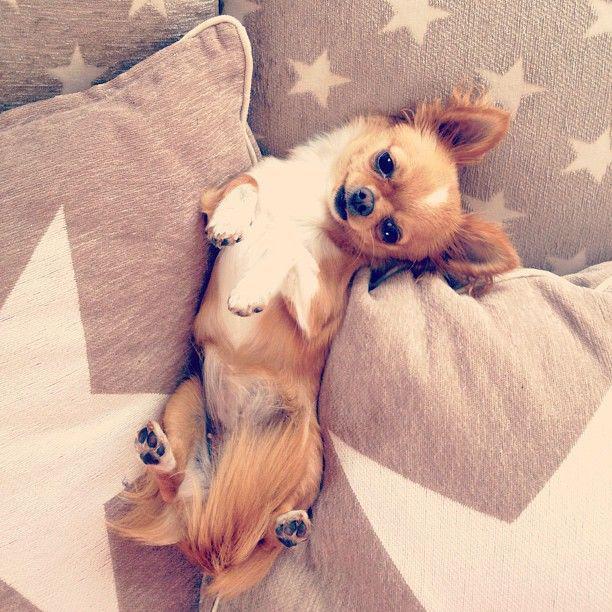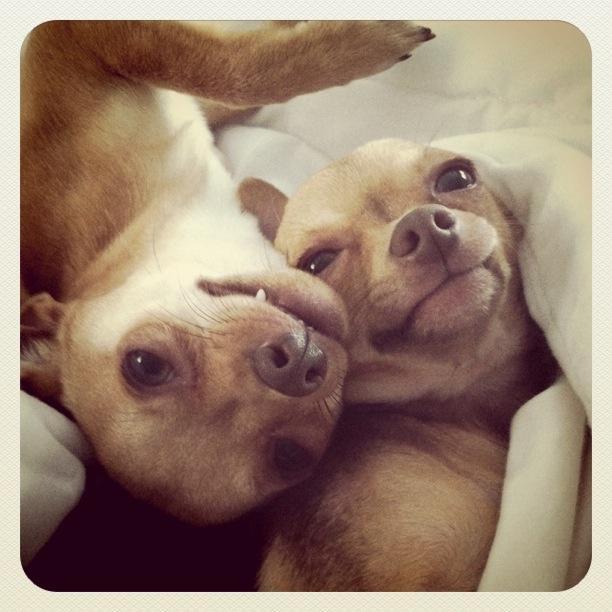The first image is the image on the left, the second image is the image on the right. For the images displayed, is the sentence "All of the dogs are real and some are dressed like humans." factually correct? Answer yes or no. No. The first image is the image on the left, the second image is the image on the right. Assess this claim about the two images: "At least two dogs are snuggling together.". Correct or not? Answer yes or no. Yes. 